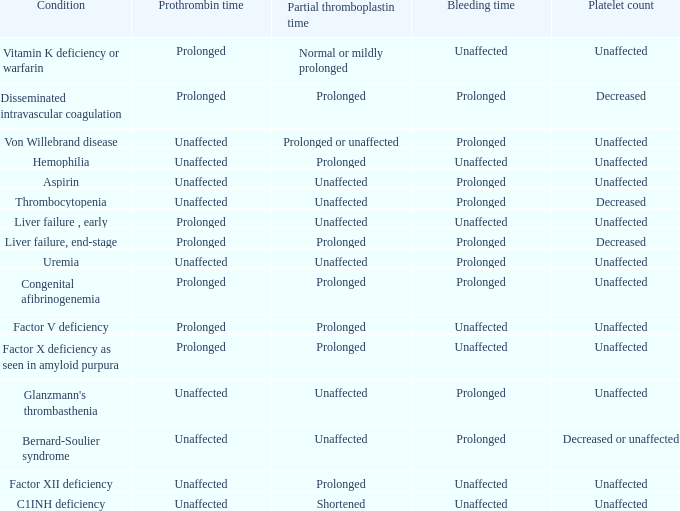Which Condition has an unaffected Partial thromboplastin time, Platelet count, and a Prothrombin time? Aspirin, Uremia, Glanzmann's thrombasthenia. 